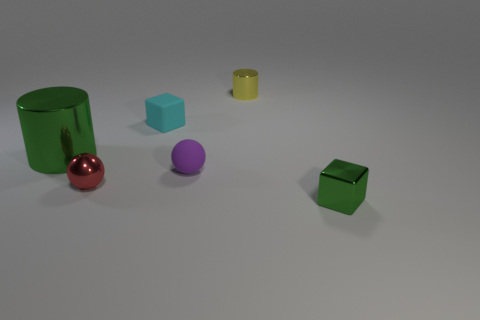There is a tiny object that is both left of the purple matte sphere and to the right of the red metal object; what is its material?
Provide a short and direct response. Rubber. What is the size of the block that is left of the green object that is on the right side of the green metallic thing behind the small green shiny block?
Your answer should be compact. Small. Is the number of tiny shiny balls greater than the number of small objects?
Make the answer very short. No. Do the tiny cube that is in front of the large metal thing and the purple ball have the same material?
Keep it short and to the point. No. Is the number of red shiny objects less than the number of big blue matte blocks?
Ensure brevity in your answer.  No. There is a rubber object in front of the large cylinder in front of the tiny cyan thing; are there any metallic cylinders on the left side of it?
Give a very brief answer. Yes. Does the small red metallic object that is in front of the large metal object have the same shape as the large object?
Offer a very short reply. No. Is the number of tiny red balls to the right of the tiny cylinder greater than the number of tiny green metal blocks?
Your answer should be compact. No. There is a cube that is behind the big green thing; is its color the same as the metallic sphere?
Your response must be concise. No. Is there any other thing that is the same color as the metal cube?
Make the answer very short. Yes. 